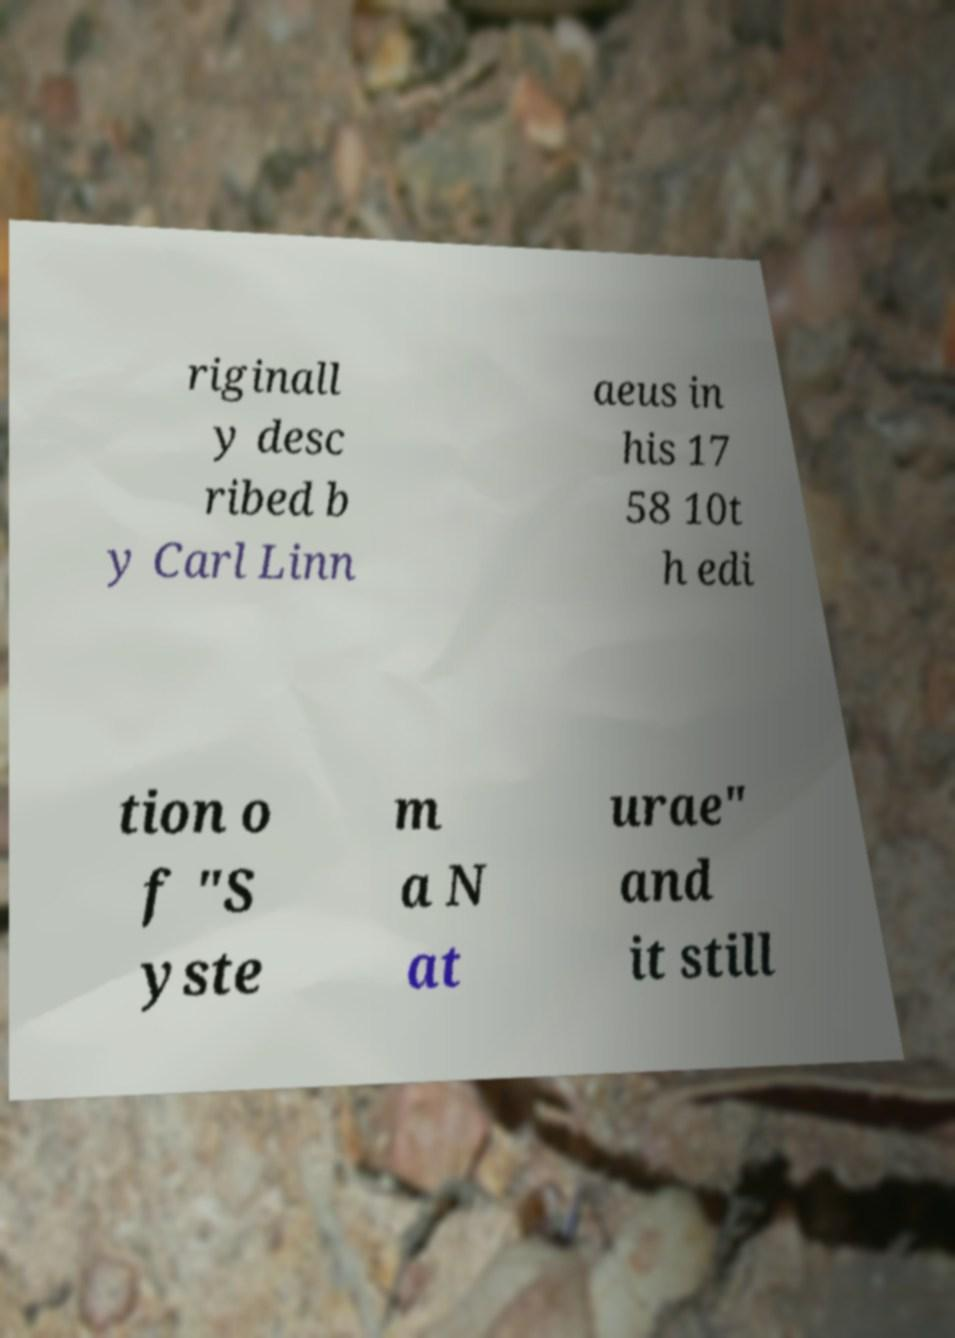For documentation purposes, I need the text within this image transcribed. Could you provide that? riginall y desc ribed b y Carl Linn aeus in his 17 58 10t h edi tion o f "S yste m a N at urae" and it still 